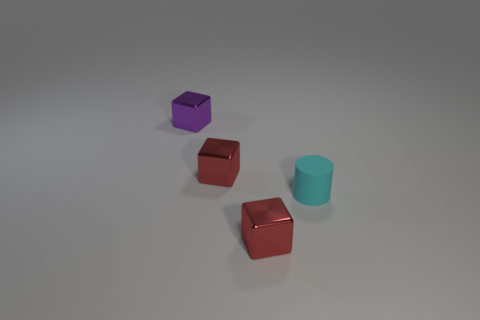Add 4 matte cylinders. How many objects exist? 8 Subtract all blocks. How many objects are left? 1 Subtract all small metal cubes. Subtract all tiny cylinders. How many objects are left? 0 Add 3 purple shiny things. How many purple shiny things are left? 4 Add 1 small purple objects. How many small purple objects exist? 2 Subtract 1 cyan cylinders. How many objects are left? 3 